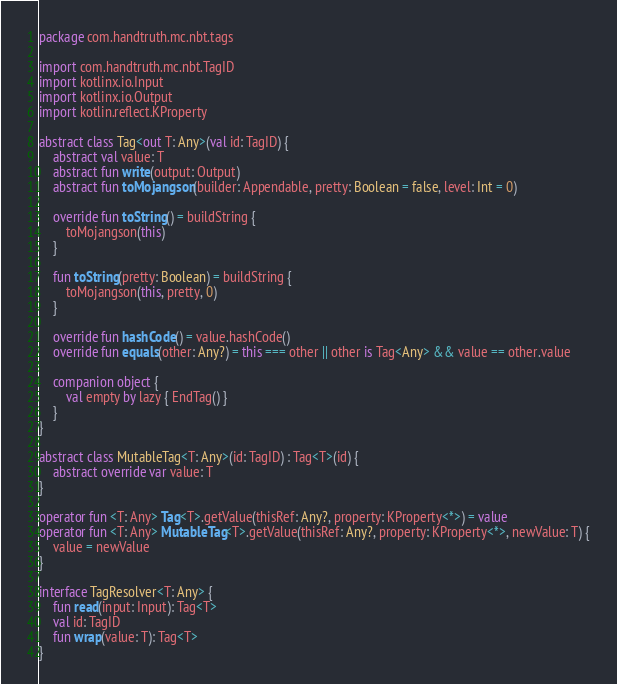Convert code to text. <code><loc_0><loc_0><loc_500><loc_500><_Kotlin_>package com.handtruth.mc.nbt.tags

import com.handtruth.mc.nbt.TagID
import kotlinx.io.Input
import kotlinx.io.Output
import kotlin.reflect.KProperty

abstract class Tag<out T: Any>(val id: TagID) {
    abstract val value: T
    abstract fun write(output: Output)
    abstract fun toMojangson(builder: Appendable, pretty: Boolean = false, level: Int = 0)

    override fun toString() = buildString {
        toMojangson(this)
    }

    fun toString(pretty: Boolean) = buildString {
        toMojangson(this, pretty, 0)
    }

    override fun hashCode() = value.hashCode()
    override fun equals(other: Any?) = this === other || other is Tag<Any> && value == other.value

    companion object {
        val empty by lazy { EndTag() }
    }
}

abstract class MutableTag<T: Any>(id: TagID) : Tag<T>(id) {
    abstract override var value: T
}

operator fun <T: Any> Tag<T>.getValue(thisRef: Any?, property: KProperty<*>) = value
operator fun <T: Any> MutableTag<T>.getValue(thisRef: Any?, property: KProperty<*>, newValue: T) {
    value = newValue
}

interface TagResolver<T: Any> {
    fun read(input: Input): Tag<T>
    val id: TagID
    fun wrap(value: T): Tag<T>
}
</code> 